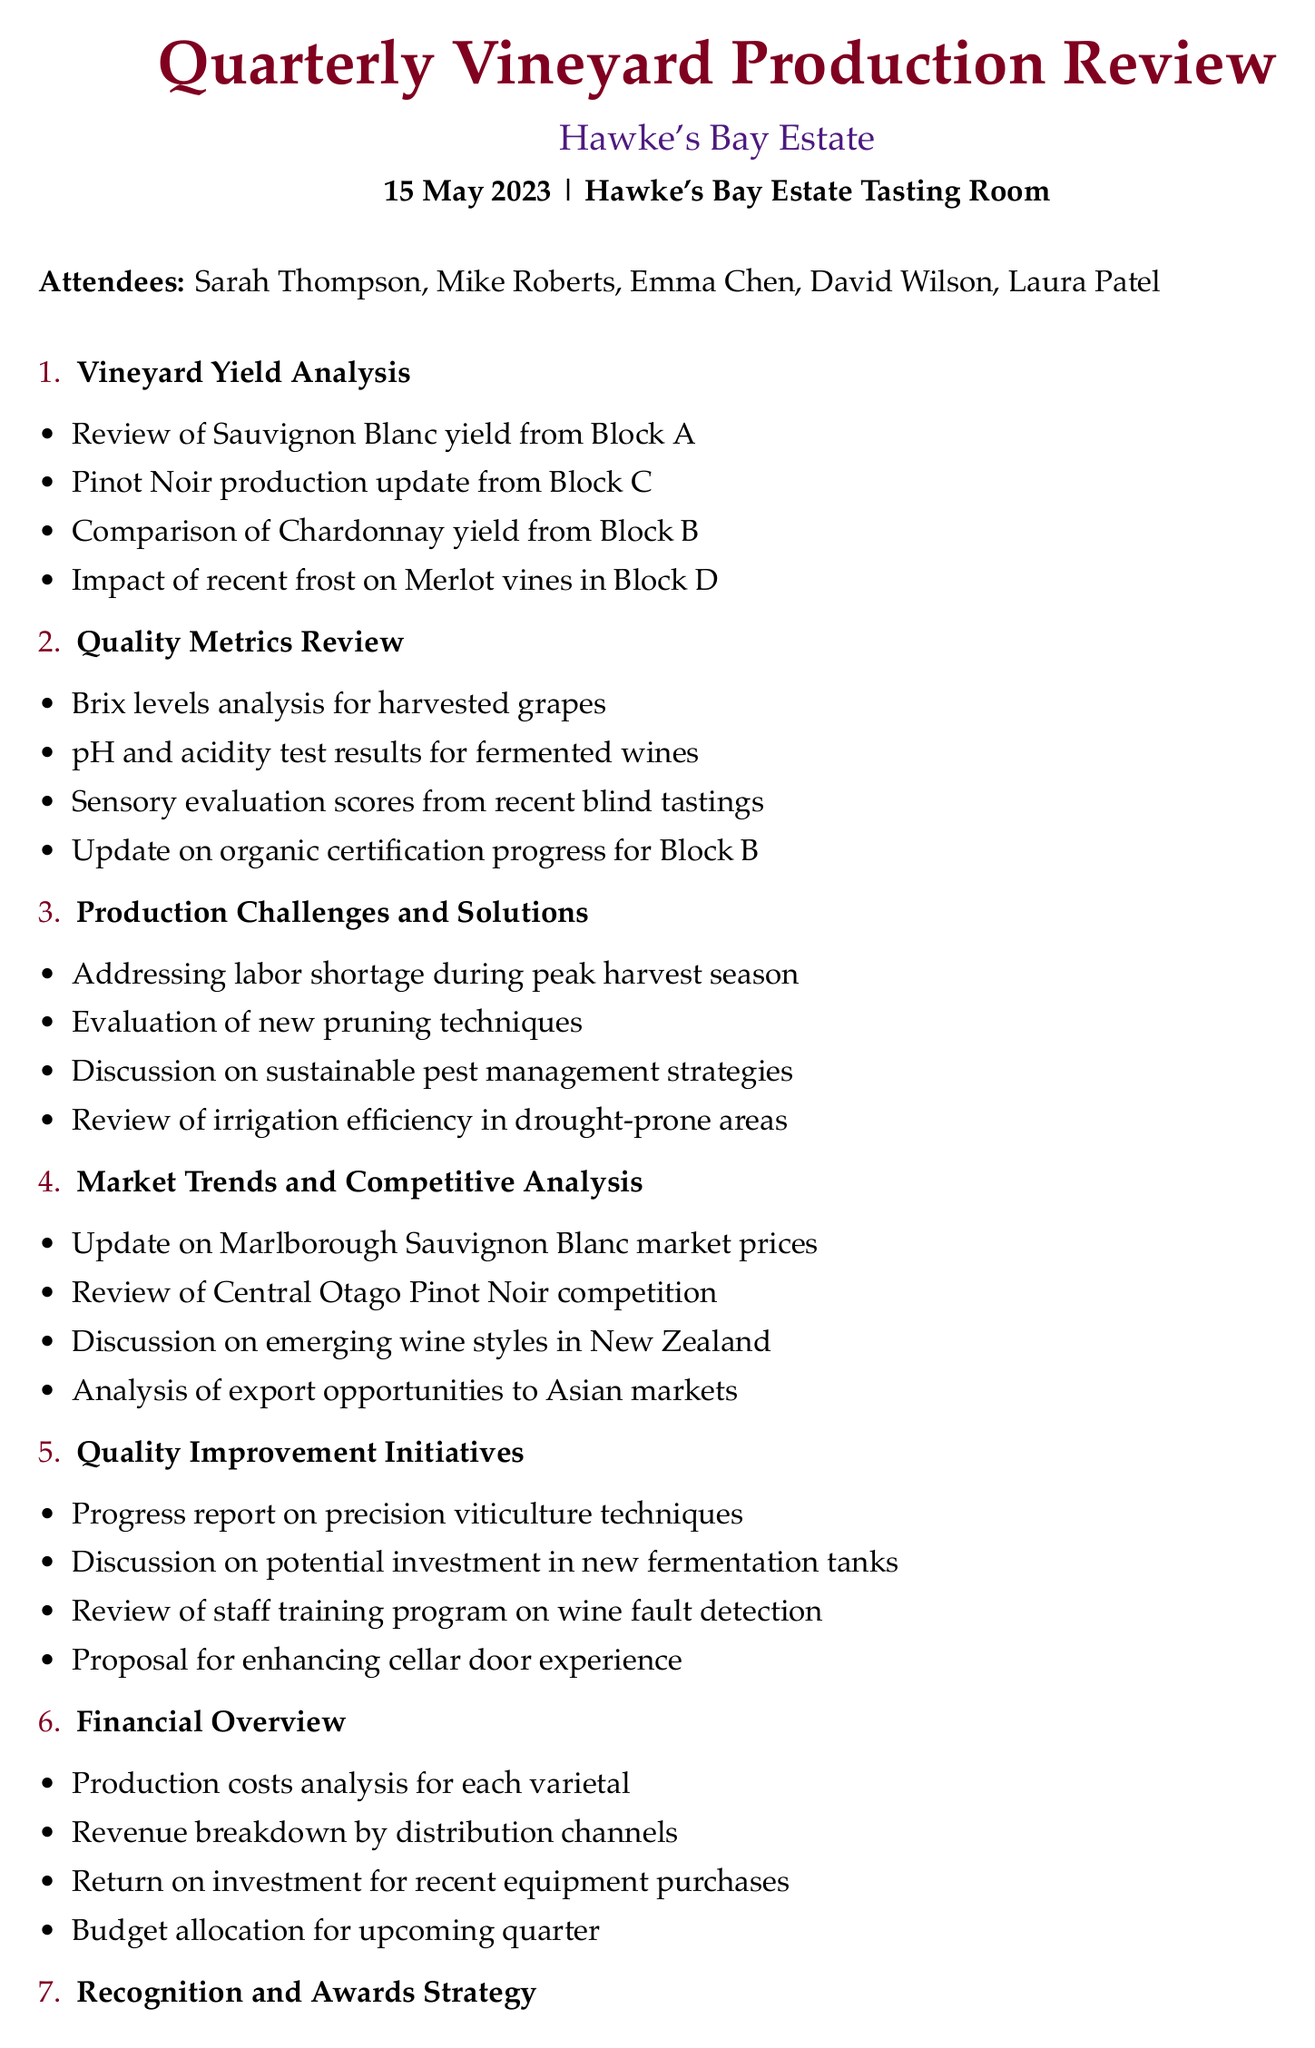What is the meeting date? The meeting date is explicitly mentioned in the document as 15 May 2023.
Answer: 15 May 2023 Who is the vineyard manager? The vineyard manager's name is listed under attendees, which is Mike Roberts.
Answer: Mike Roberts What varietal's yield is being reviewed from Block A? The varietal yield being reviewed from Block A is Sauvignon Blanc, as noted in the Vineyard Yield Analysis.
Answer: Sauvignon Blanc What quality metric is analyzed for the harvested grapes? Brix levels analysis is mentioned as one of the quality metrics in the Quality Metrics Review section.
Answer: Brix levels What action item pertains to staff training? The action item related to staff training includes scheduling a session on new quality control procedures as indicated in the action items section.
Answer: Schedule staff training session on new quality control procedures How many attendees are listed in the document? The document lists five attendees, which can be counted from the attendees section.
Answer: 5 What is being discussed for improvement in the vineyard? The proposal for enhancing cellar door experience is one of the improvements discussed in the Quality Improvement Initiatives section.
Answer: Enhancing cellar door experience Which market's wine prices are being updated? The update pertains to Marlborough Sauvignon Blanc market prices, which are covered in the Market Trends and Competitive Analysis section.
Answer: Marlborough Sauvignon Blanc What is one of the production challenges mentioned? Addressing labor shortage during peak harvest season is noted as a production challenge in the document.
Answer: Labor shortage during peak harvest season 